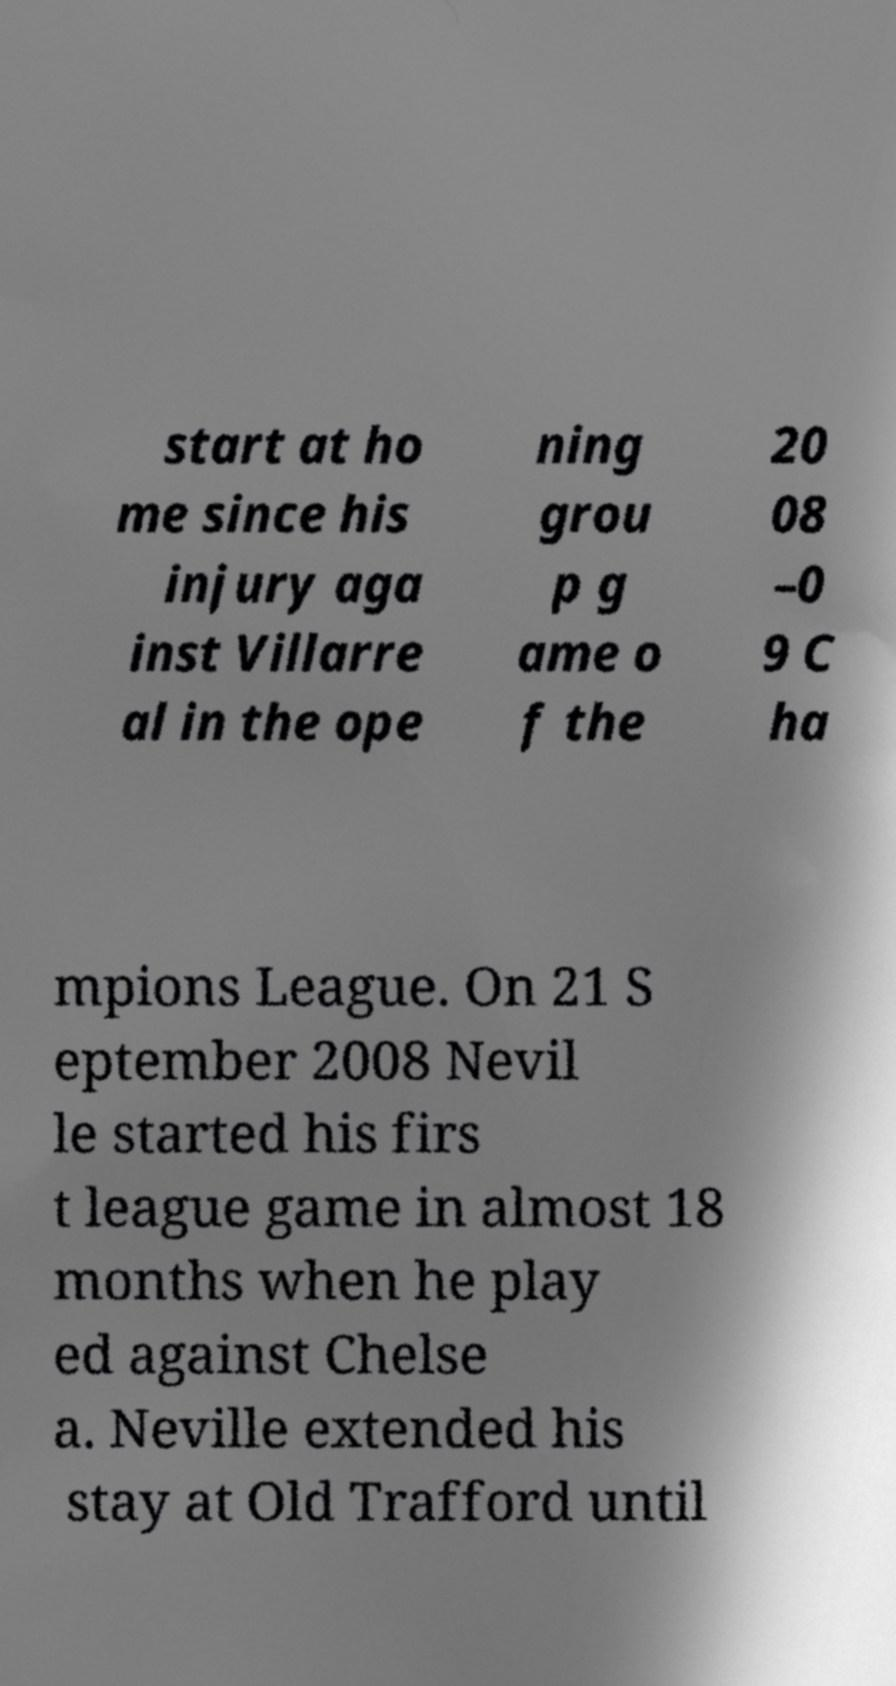I need the written content from this picture converted into text. Can you do that? start at ho me since his injury aga inst Villarre al in the ope ning grou p g ame o f the 20 08 –0 9 C ha mpions League. On 21 S eptember 2008 Nevil le started his firs t league game in almost 18 months when he play ed against Chelse a. Neville extended his stay at Old Trafford until 